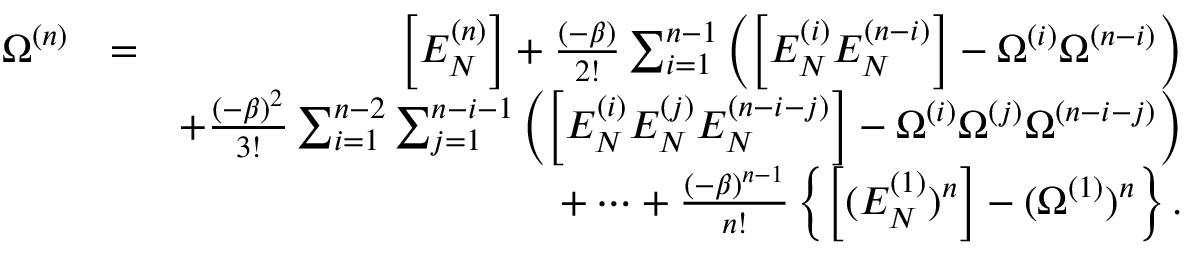Convert formula to latex. <formula><loc_0><loc_0><loc_500><loc_500>\begin{array} { r l r } { \Omega ^ { ( n ) } } & { = } & { \left [ E _ { N } ^ { ( n ) } \right ] + \frac { ( - \beta ) } { 2 ! } \sum _ { i = 1 } ^ { n - 1 } \left ( \left [ E _ { N } ^ { ( i ) } E _ { N } ^ { ( n - i ) } \right ] - \Omega ^ { ( i ) } \Omega ^ { ( n - i ) } \right ) } \\ & { + \frac { ( - \beta ) ^ { 2 } } { 3 ! } \sum _ { i = 1 } ^ { n - 2 } \sum _ { j = 1 } ^ { n - i - 1 } \left ( \left [ E _ { N } ^ { ( i ) } E _ { N } ^ { ( j ) } E _ { N } ^ { ( n - i - j ) } \right ] - \Omega ^ { ( i ) } \Omega ^ { ( j ) } \Omega ^ { ( n - i - j ) } \right ) } \\ & { + \cdots + \frac { ( - \beta ) ^ { n - 1 } } { n ! } \left \{ \left [ ( E _ { N } ^ { ( 1 ) } ) ^ { n } \right ] - ( \Omega ^ { ( 1 ) } ) ^ { n } \right \} . } \end{array}</formula> 